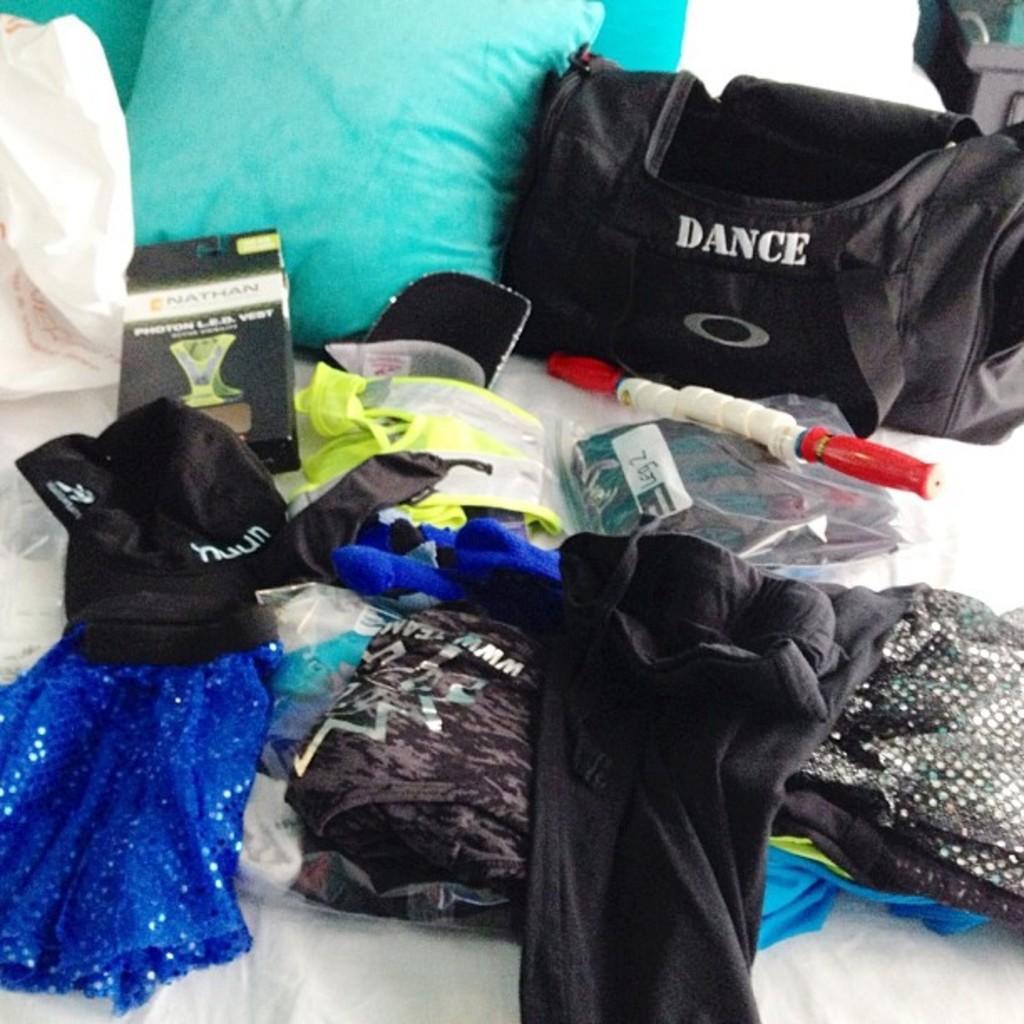Describe this image in one or two sentences. This picture shows few clothes and a box cab and a bag couple of pillows and a carry bag on the bed. 